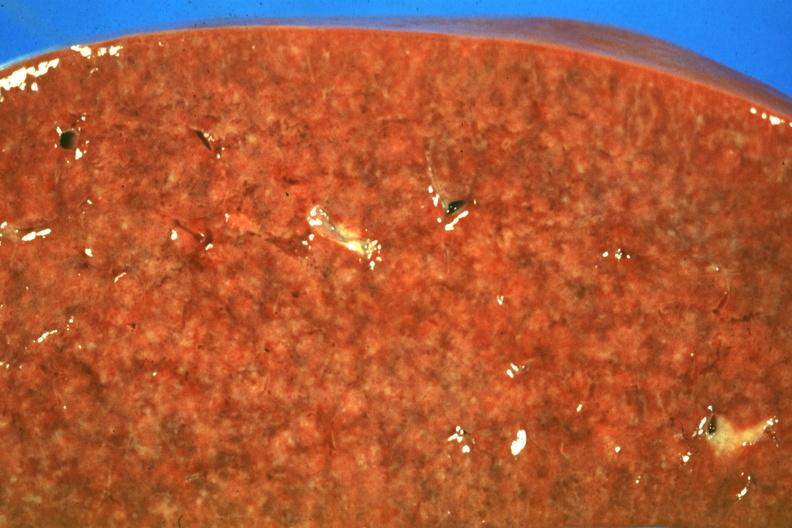s spleen present?
Answer the question using a single word or phrase. Yes 